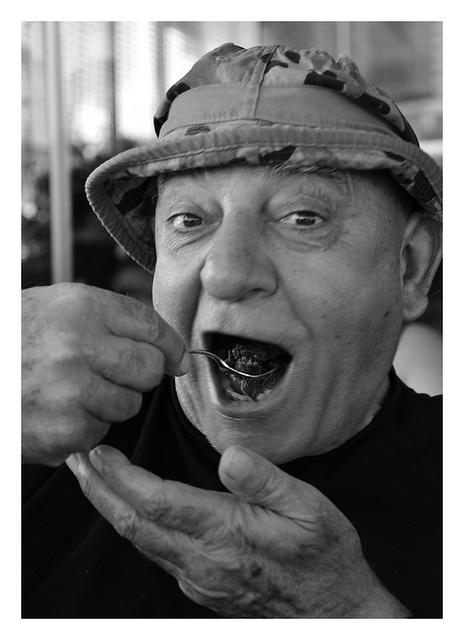What is the man putting in his mouth?
Be succinct. Spoon. Is this black and white?
Concise answer only. Yes. Is the man eating?
Write a very short answer. Yes. 